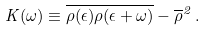Convert formula to latex. <formula><loc_0><loc_0><loc_500><loc_500>K ( \omega ) \equiv \overline { \rho ( \epsilon ) \rho ( \epsilon + \omega ) } - \overline { \rho } ^ { 2 } \, .</formula> 